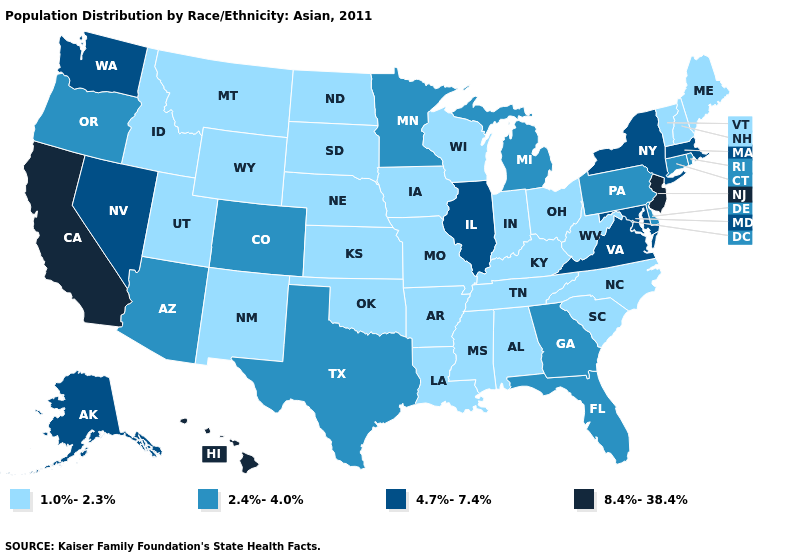Name the states that have a value in the range 8.4%-38.4%?
Give a very brief answer. California, Hawaii, New Jersey. Among the states that border Florida , which have the lowest value?
Be succinct. Alabama. What is the value of West Virginia?
Give a very brief answer. 1.0%-2.3%. Among the states that border Arizona , which have the highest value?
Keep it brief. California. Is the legend a continuous bar?
Quick response, please. No. Does Alaska have the highest value in the USA?
Give a very brief answer. No. What is the value of New York?
Concise answer only. 4.7%-7.4%. Name the states that have a value in the range 2.4%-4.0%?
Short answer required. Arizona, Colorado, Connecticut, Delaware, Florida, Georgia, Michigan, Minnesota, Oregon, Pennsylvania, Rhode Island, Texas. Name the states that have a value in the range 8.4%-38.4%?
Concise answer only. California, Hawaii, New Jersey. Does Ohio have a lower value than Colorado?
Keep it brief. Yes. Does the map have missing data?
Short answer required. No. Does California have the highest value in the West?
Short answer required. Yes. Among the states that border Idaho , which have the lowest value?
Short answer required. Montana, Utah, Wyoming. What is the value of New Mexico?
Concise answer only. 1.0%-2.3%. What is the value of Kentucky?
Write a very short answer. 1.0%-2.3%. 